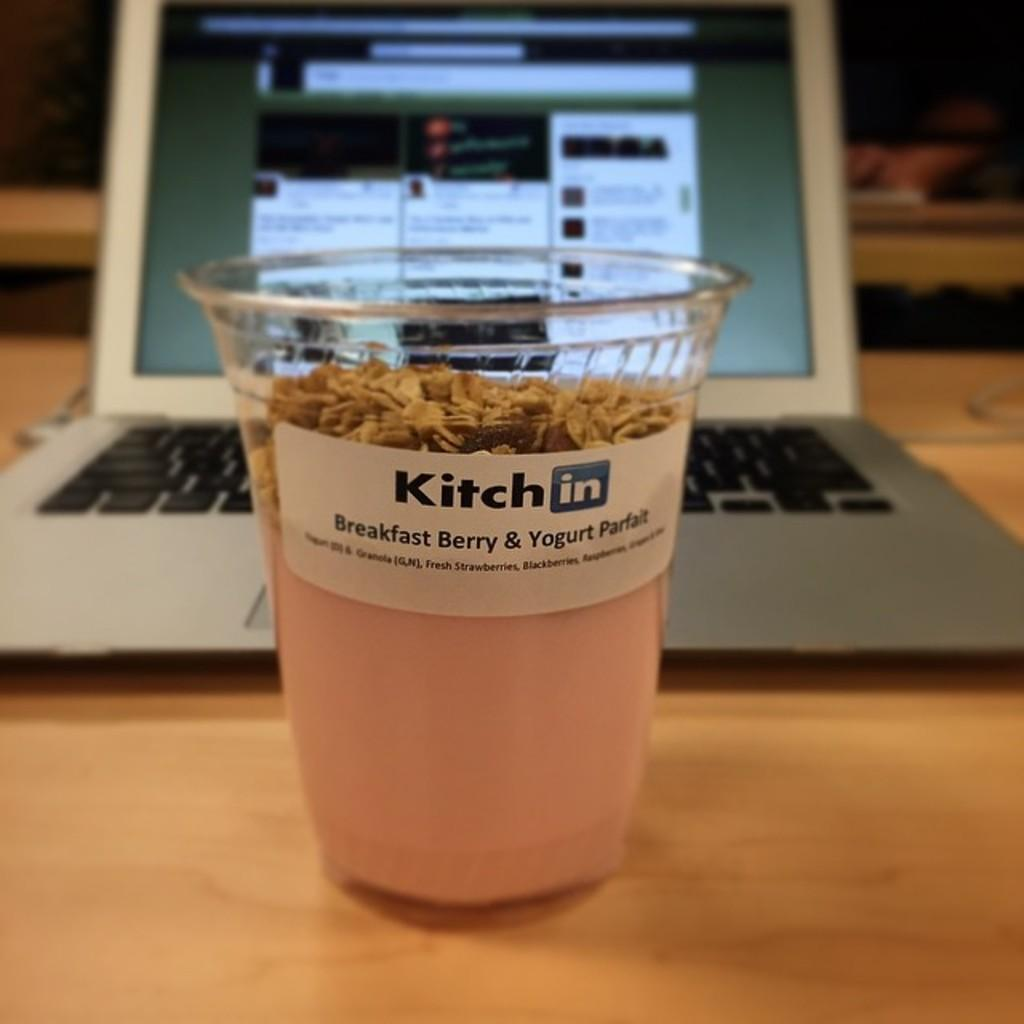What is inside the disposal tumbler in the image? There is a smoothie inside the disposal tumbler in the image. What electronic device can be seen in the image? There is a laptop in the image. What type of surface is visible in the image? The wooden surface is present in the image. What type of drum is being played in the image? There is no drum present in the image. What type of wire is connected to the laptop? There is no wire connected to the laptop in the image. 